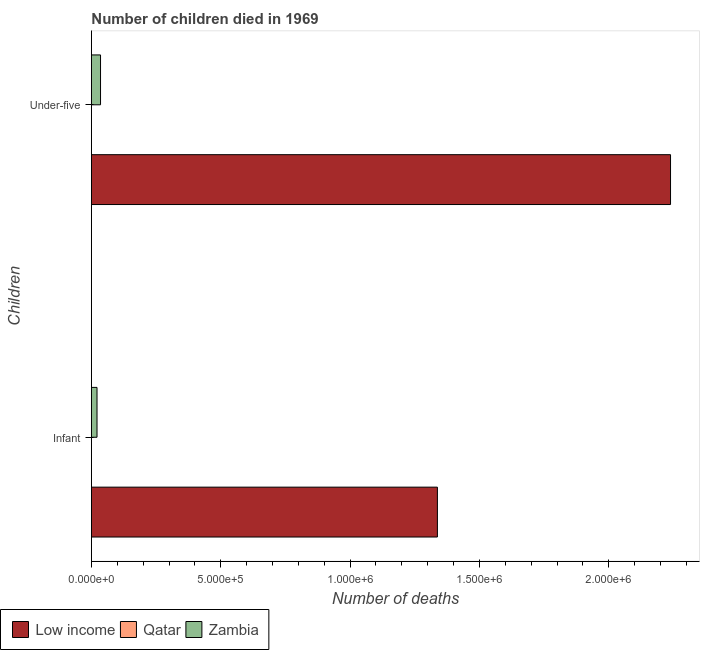How many groups of bars are there?
Your answer should be very brief. 2. What is the label of the 1st group of bars from the top?
Make the answer very short. Under-five. What is the number of under-five deaths in Low income?
Give a very brief answer. 2.24e+06. Across all countries, what is the maximum number of under-five deaths?
Keep it short and to the point. 2.24e+06. Across all countries, what is the minimum number of infant deaths?
Make the answer very short. 197. In which country was the number of infant deaths maximum?
Your response must be concise. Low income. In which country was the number of infant deaths minimum?
Offer a terse response. Qatar. What is the total number of infant deaths in the graph?
Provide a succinct answer. 1.36e+06. What is the difference between the number of infant deaths in Qatar and that in Zambia?
Give a very brief answer. -2.14e+04. What is the difference between the number of under-five deaths in Qatar and the number of infant deaths in Low income?
Offer a very short reply. -1.34e+06. What is the average number of under-five deaths per country?
Offer a very short reply. 7.58e+05. What is the difference between the number of under-five deaths and number of infant deaths in Zambia?
Make the answer very short. 1.36e+04. What is the ratio of the number of infant deaths in Low income to that in Zambia?
Your answer should be compact. 61.88. What does the 2nd bar from the top in Infant represents?
Make the answer very short. Qatar. What does the 3rd bar from the bottom in Under-five represents?
Provide a succinct answer. Zambia. How many countries are there in the graph?
Make the answer very short. 3. What is the difference between two consecutive major ticks on the X-axis?
Ensure brevity in your answer.  5.00e+05. Are the values on the major ticks of X-axis written in scientific E-notation?
Offer a terse response. Yes. Does the graph contain any zero values?
Keep it short and to the point. No. Where does the legend appear in the graph?
Keep it short and to the point. Bottom left. What is the title of the graph?
Give a very brief answer. Number of children died in 1969. Does "Vietnam" appear as one of the legend labels in the graph?
Give a very brief answer. No. What is the label or title of the X-axis?
Offer a very short reply. Number of deaths. What is the label or title of the Y-axis?
Offer a very short reply. Children. What is the Number of deaths in Low income in Infant?
Give a very brief answer. 1.34e+06. What is the Number of deaths in Qatar in Infant?
Provide a succinct answer. 197. What is the Number of deaths in Zambia in Infant?
Keep it short and to the point. 2.16e+04. What is the Number of deaths of Low income in Under-five?
Give a very brief answer. 2.24e+06. What is the Number of deaths in Qatar in Under-five?
Keep it short and to the point. 254. What is the Number of deaths in Zambia in Under-five?
Give a very brief answer. 3.52e+04. Across all Children, what is the maximum Number of deaths of Low income?
Your answer should be very brief. 2.24e+06. Across all Children, what is the maximum Number of deaths in Qatar?
Make the answer very short. 254. Across all Children, what is the maximum Number of deaths in Zambia?
Your response must be concise. 3.52e+04. Across all Children, what is the minimum Number of deaths in Low income?
Make the answer very short. 1.34e+06. Across all Children, what is the minimum Number of deaths in Qatar?
Your answer should be compact. 197. Across all Children, what is the minimum Number of deaths of Zambia?
Make the answer very short. 2.16e+04. What is the total Number of deaths in Low income in the graph?
Provide a succinct answer. 3.58e+06. What is the total Number of deaths in Qatar in the graph?
Your answer should be very brief. 451. What is the total Number of deaths of Zambia in the graph?
Provide a short and direct response. 5.68e+04. What is the difference between the Number of deaths in Low income in Infant and that in Under-five?
Provide a succinct answer. -9.01e+05. What is the difference between the Number of deaths in Qatar in Infant and that in Under-five?
Your response must be concise. -57. What is the difference between the Number of deaths in Zambia in Infant and that in Under-five?
Make the answer very short. -1.36e+04. What is the difference between the Number of deaths of Low income in Infant and the Number of deaths of Qatar in Under-five?
Your answer should be compact. 1.34e+06. What is the difference between the Number of deaths of Low income in Infant and the Number of deaths of Zambia in Under-five?
Keep it short and to the point. 1.30e+06. What is the difference between the Number of deaths of Qatar in Infant and the Number of deaths of Zambia in Under-five?
Provide a short and direct response. -3.50e+04. What is the average Number of deaths in Low income per Children?
Offer a very short reply. 1.79e+06. What is the average Number of deaths in Qatar per Children?
Give a very brief answer. 225.5. What is the average Number of deaths of Zambia per Children?
Your answer should be compact. 2.84e+04. What is the difference between the Number of deaths of Low income and Number of deaths of Qatar in Infant?
Offer a terse response. 1.34e+06. What is the difference between the Number of deaths in Low income and Number of deaths in Zambia in Infant?
Ensure brevity in your answer.  1.32e+06. What is the difference between the Number of deaths of Qatar and Number of deaths of Zambia in Infant?
Keep it short and to the point. -2.14e+04. What is the difference between the Number of deaths in Low income and Number of deaths in Qatar in Under-five?
Provide a short and direct response. 2.24e+06. What is the difference between the Number of deaths of Low income and Number of deaths of Zambia in Under-five?
Make the answer very short. 2.20e+06. What is the difference between the Number of deaths of Qatar and Number of deaths of Zambia in Under-five?
Offer a terse response. -3.49e+04. What is the ratio of the Number of deaths of Low income in Infant to that in Under-five?
Your response must be concise. 0.6. What is the ratio of the Number of deaths of Qatar in Infant to that in Under-five?
Ensure brevity in your answer.  0.78. What is the ratio of the Number of deaths in Zambia in Infant to that in Under-five?
Keep it short and to the point. 0.61. What is the difference between the highest and the second highest Number of deaths in Low income?
Offer a terse response. 9.01e+05. What is the difference between the highest and the second highest Number of deaths of Zambia?
Make the answer very short. 1.36e+04. What is the difference between the highest and the lowest Number of deaths in Low income?
Offer a very short reply. 9.01e+05. What is the difference between the highest and the lowest Number of deaths in Qatar?
Give a very brief answer. 57. What is the difference between the highest and the lowest Number of deaths of Zambia?
Ensure brevity in your answer.  1.36e+04. 